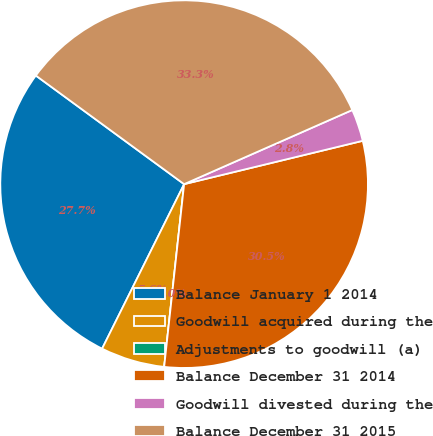Convert chart. <chart><loc_0><loc_0><loc_500><loc_500><pie_chart><fcel>Balance January 1 2014<fcel>Goodwill acquired during the<fcel>Adjustments to goodwill (a)<fcel>Balance December 31 2014<fcel>Goodwill divested during the<fcel>Balance December 31 2015<nl><fcel>27.7%<fcel>5.63%<fcel>0.0%<fcel>30.52%<fcel>2.82%<fcel>33.33%<nl></chart> 